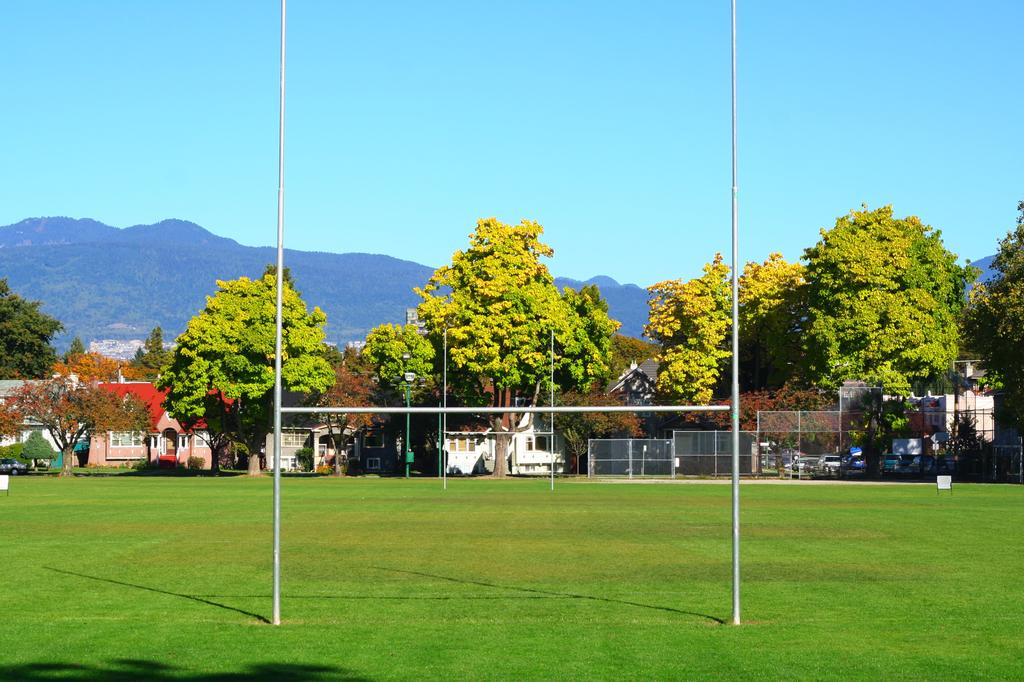What type of structures can be seen in the image? There are fences and houses in the image. What type of objects are present in the image? There are rods, vehicles, and trees in the image. What is visible at the bottom of the image? Grass is visible at the bottom of the image. What can be seen in the background of the image? There are hills and the sky visible in the background of the image. How many cherries are being bitten in the image? There are no cherries present in the image, and therefore no one is biting any cherries. What unit of measurement is used to determine the length of the rods in the image? The provided facts do not specify a unit of measurement for the rods, so it cannot be determined from the image. 